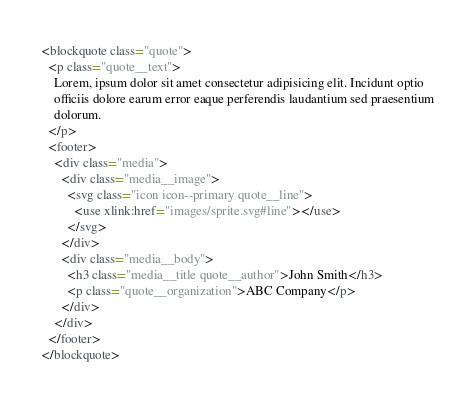Convert code to text. <code><loc_0><loc_0><loc_500><loc_500><_HTML_><blockquote class="quote">
  <p class="quote__text">
    Lorem, ipsum dolor sit amet consectetur adipisicing elit. Incidunt optio
    officiis dolore earum error eaque perferendis laudantium sed praesentium
    dolorum.
  </p>
  <footer>
    <div class="media">
      <div class="media__image">
        <svg class="icon icon--primary quote__line">
          <use xlink:href="images/sprite.svg#line"></use>
        </svg>
      </div>
      <div class="media__body">
        <h3 class="media__title quote__author">John Smith</h3>
        <p class="quote__organization">ABC Company</p>
      </div>
    </div>
  </footer>
</blockquote>
</code> 